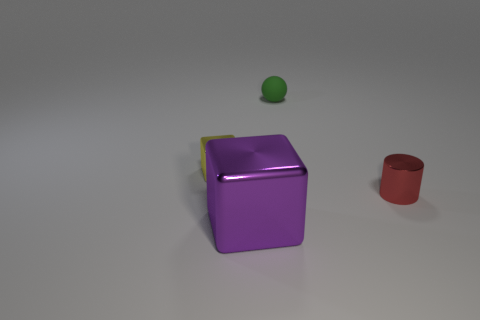Are there any other things that are the same size as the purple object?
Provide a short and direct response. No. Are there any other things that have the same shape as the small rubber thing?
Give a very brief answer. No. What number of other objects are the same size as the green matte object?
Your answer should be very brief. 2. There is a yellow metallic thing; is it the same shape as the metallic thing that is in front of the small red metallic cylinder?
Give a very brief answer. Yes. How many matte things are either cylinders or large gray cylinders?
Offer a very short reply. 0. Are any metal objects visible?
Your response must be concise. Yes. Is the purple shiny thing the same shape as the tiny yellow object?
Your response must be concise. Yes. What number of tiny objects are cyan metallic blocks or cylinders?
Ensure brevity in your answer.  1. What is the color of the tiny shiny block?
Provide a short and direct response. Yellow. What is the shape of the object that is on the left side of the block in front of the tiny yellow cube?
Give a very brief answer. Cube. 